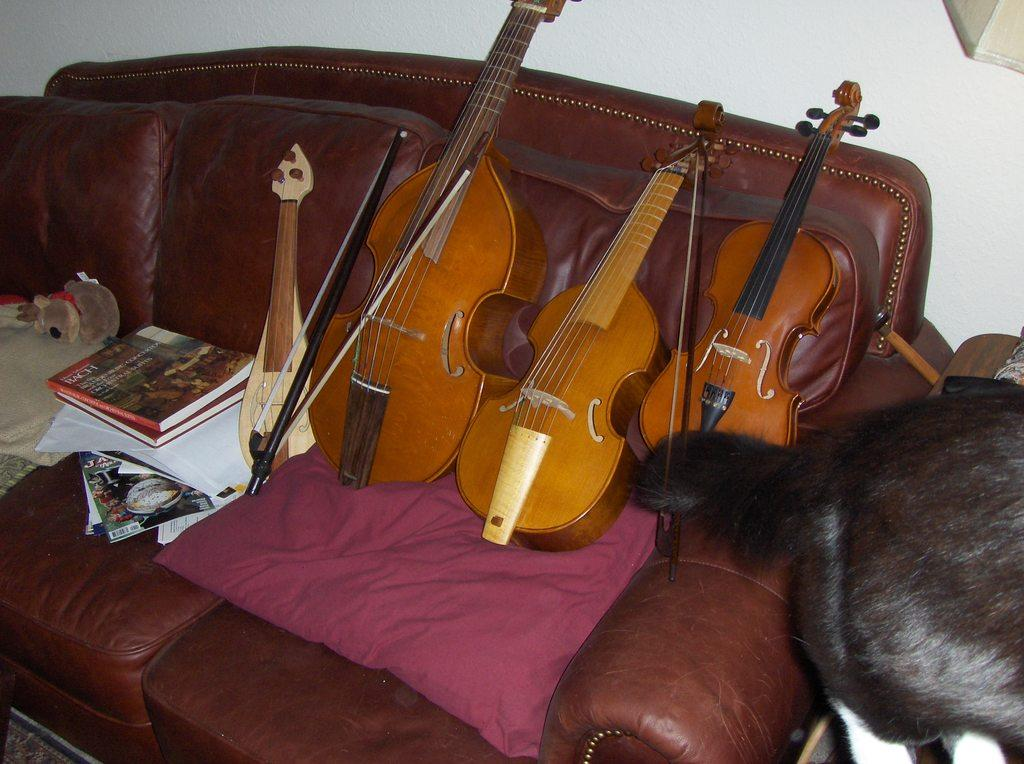What type of furniture is in the image? There is a couch in the image. What objects are placed on the couch? Guitars, a rod, a pillow, a paper, a book, and toys are placed on the couch. Can you describe the animal beside the couch? There is an animal beside the couch, but the specific type of animal is not mentioned in the facts. What might be used for comfort or decoration on the couch? The pillow on the couch might be used for comfort or decoration. How much sugar is on the couch in the image? There is no mention of sugar in the image, so it cannot be determined how much sugar is present. 